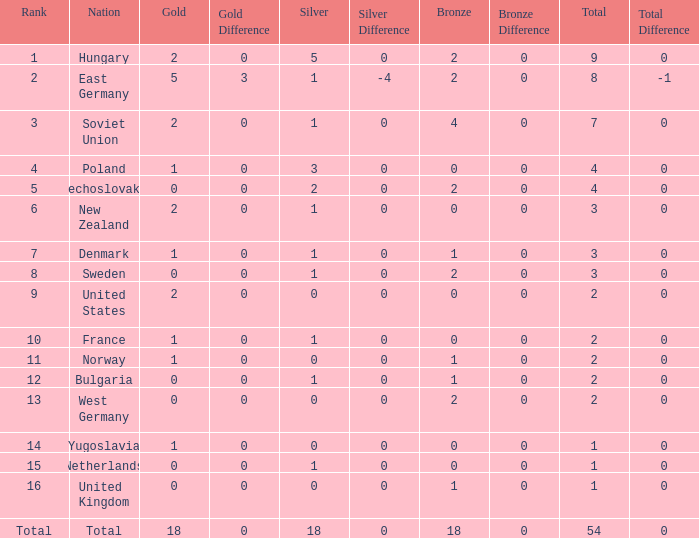What is the lowest total for those receiving less than 18 but more than 14? 1.0. 